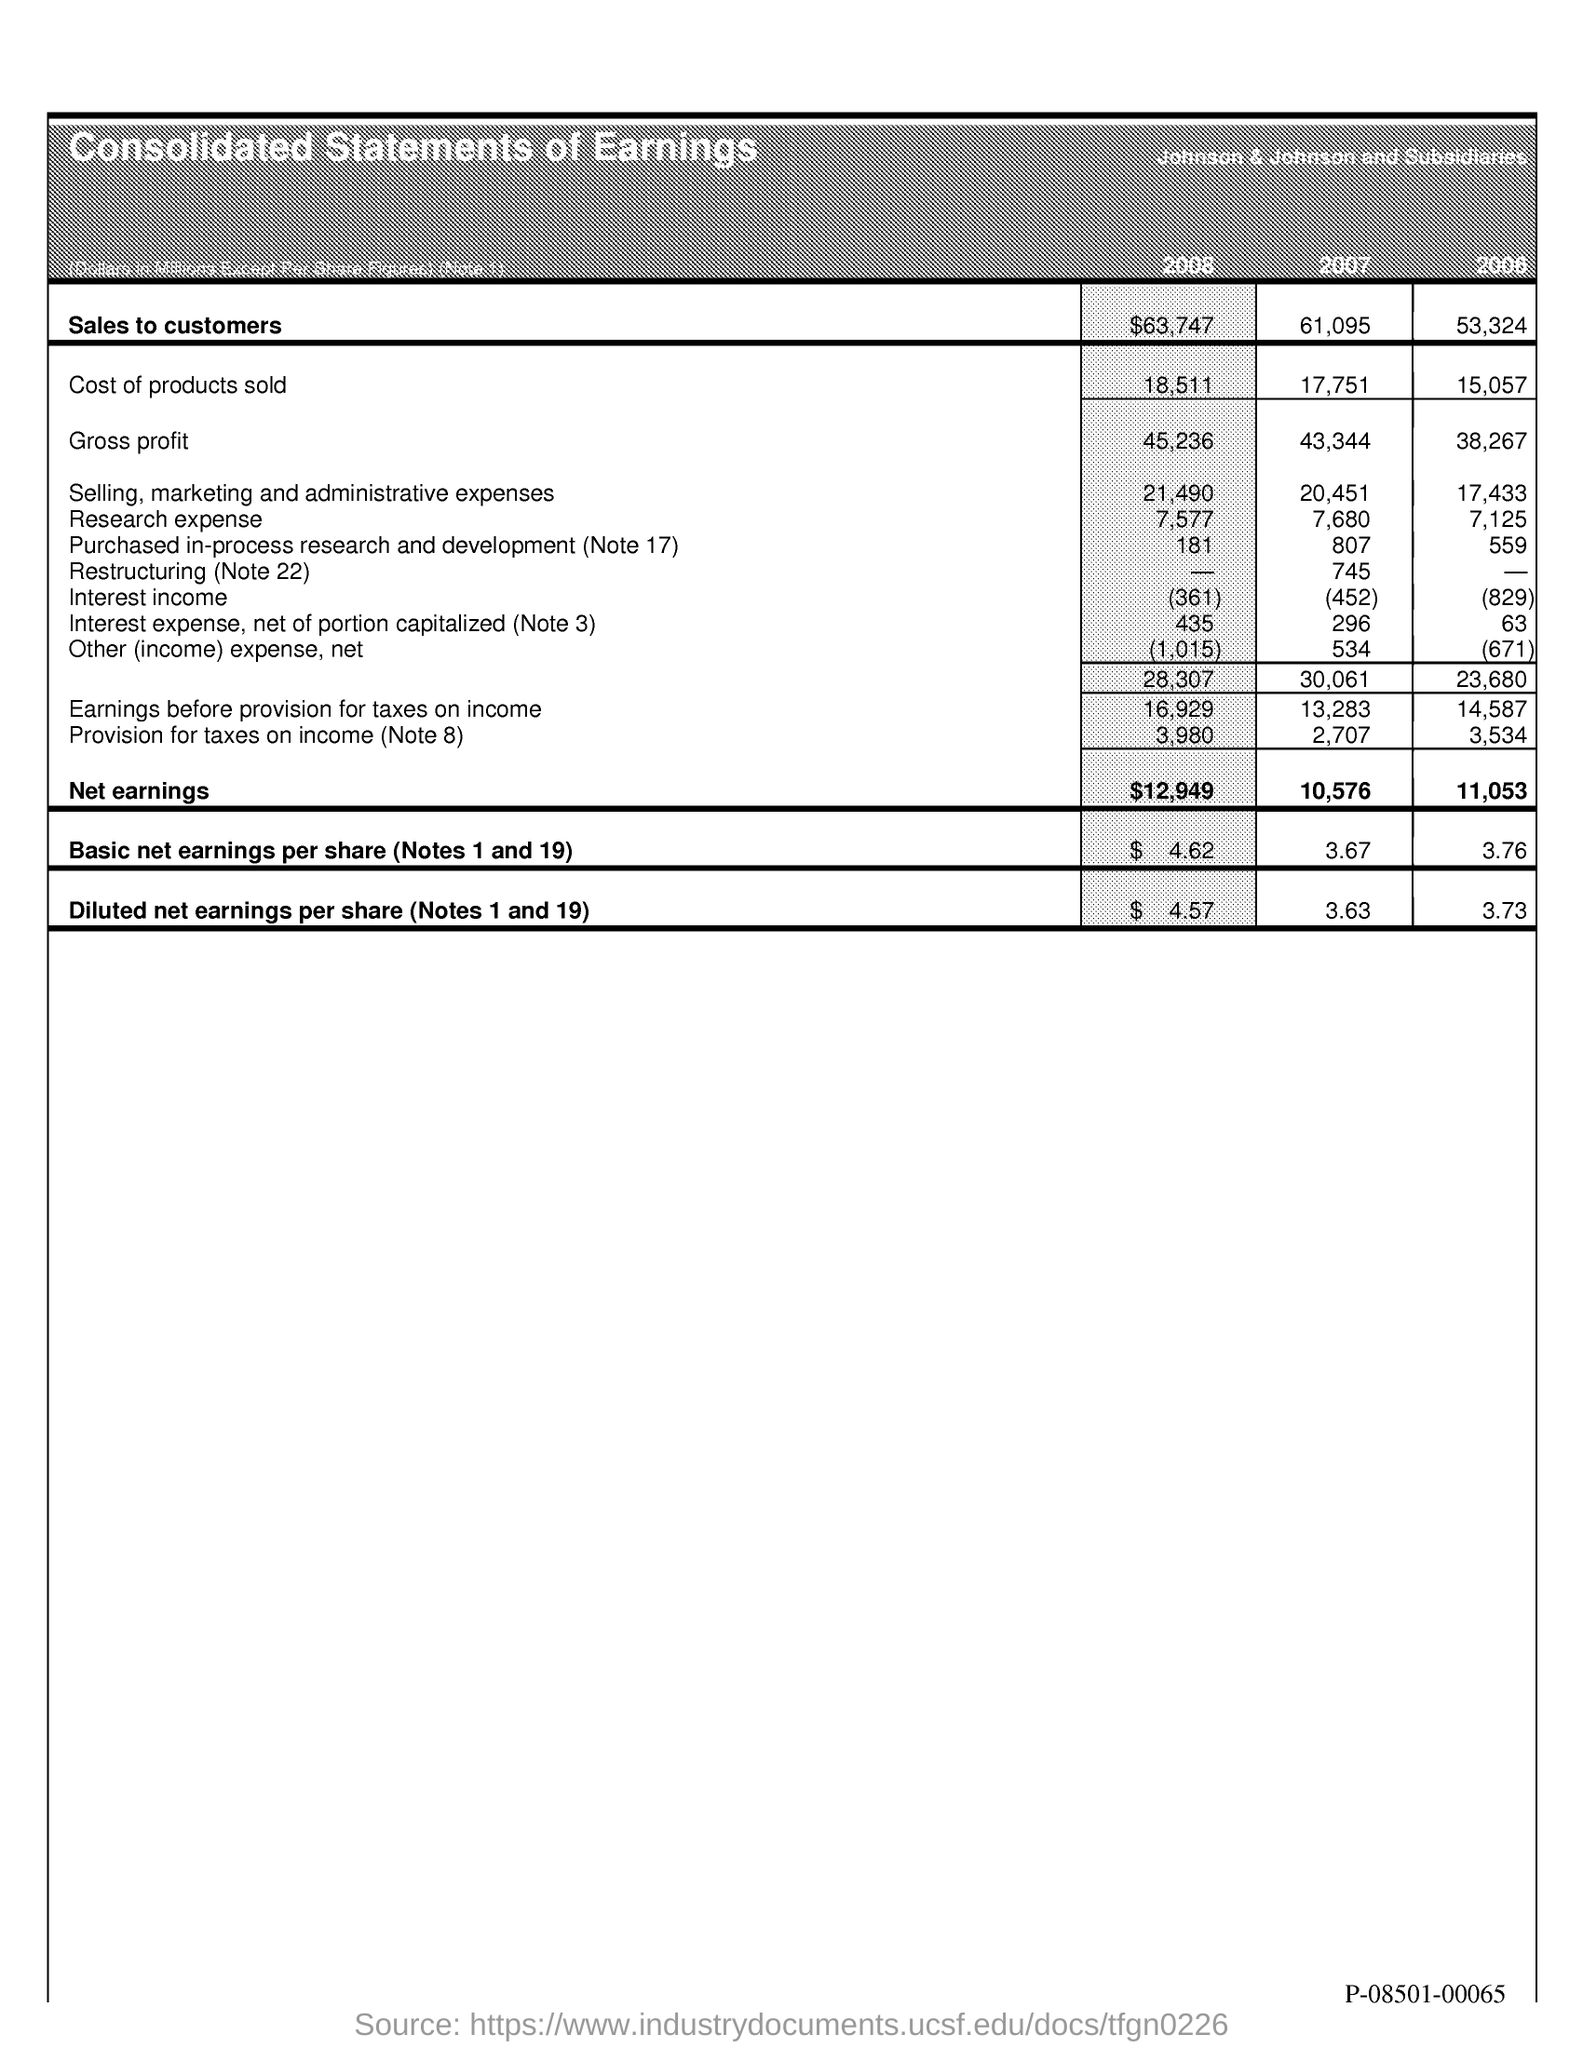List a handful of essential elements in this visual. In 2006, the sales to customers were 53,324. The cost of products sold in 2006 was 15,057. The cost of products sold in 2007 was 17,751. Basic net earnings per share for the year 2008 was $4.62, as noted in Note 1 and 19. The net earnings in 2007 were 10,576. 